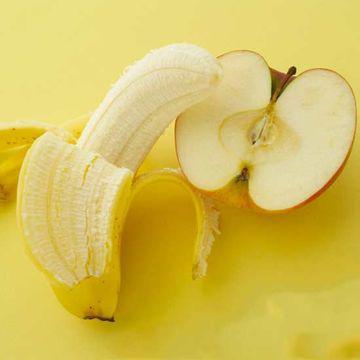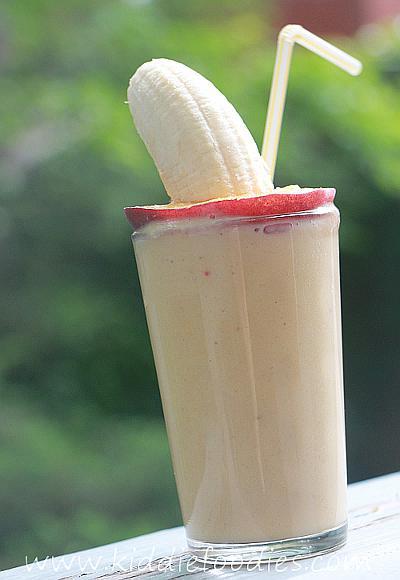The first image is the image on the left, the second image is the image on the right. Assess this claim about the two images: "There is a full white cup with one whole banana and apple on either side of it.". Correct or not? Answer yes or no. No. 